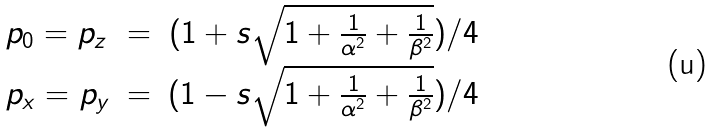Convert formula to latex. <formula><loc_0><loc_0><loc_500><loc_500>\begin{array} { l c r } p _ { 0 } = p _ { z } & = & ( 1 + s \sqrt { 1 + \frac { 1 } { \alpha ^ { 2 } } + \frac { 1 } { \beta ^ { 2 } } } ) / 4 \\ p _ { x } = p _ { y } & = & ( 1 - s \sqrt { 1 + \frac { 1 } { \alpha ^ { 2 } } + \frac { 1 } { \beta ^ { 2 } } } ) / 4 \\ \end{array}</formula> 